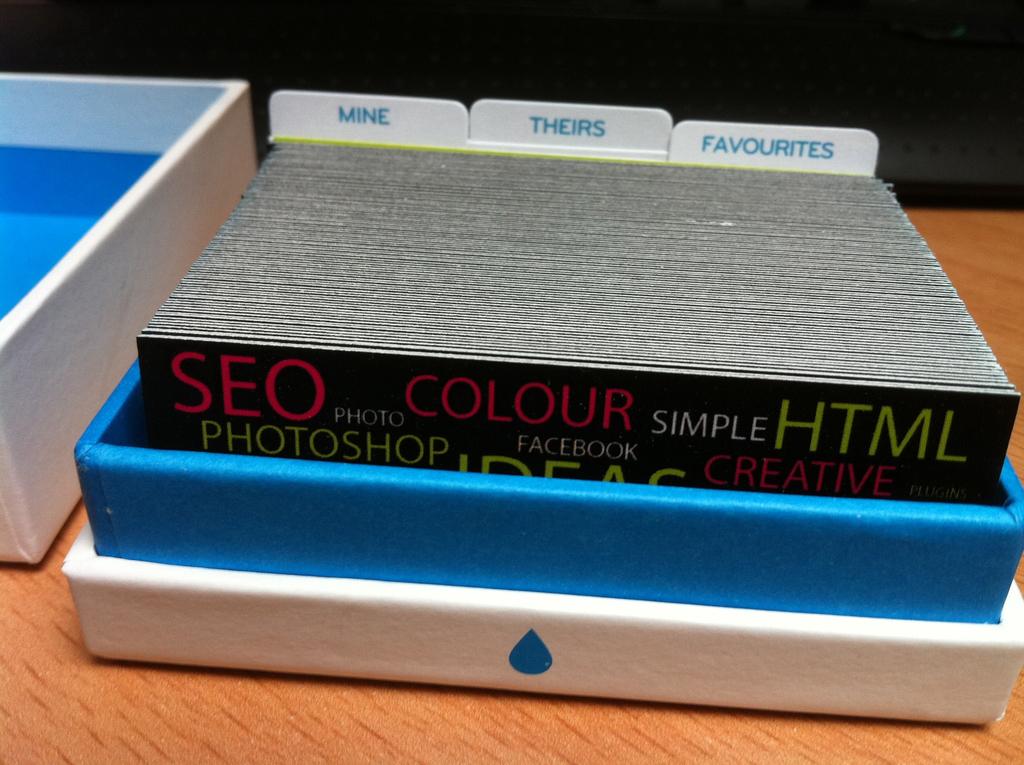What are the three words on the white dividers?
Provide a short and direct response. Mine theirs favourites. 